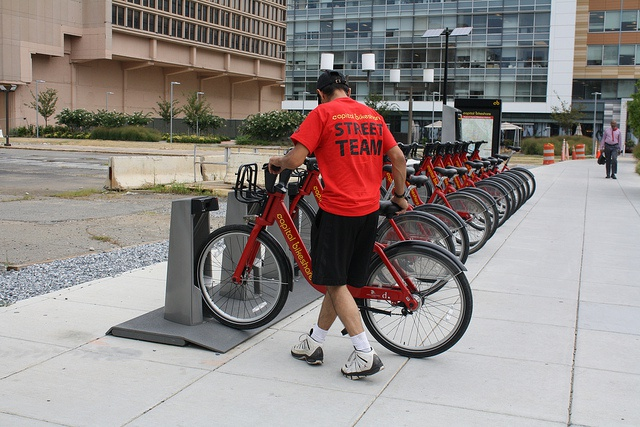Describe the objects in this image and their specific colors. I can see bicycle in gray, black, lightgray, and darkgray tones, people in gray, black, red, brown, and maroon tones, bicycle in gray, black, maroon, and darkgray tones, bicycle in gray, black, darkgray, and maroon tones, and bicycle in gray, black, darkgray, and maroon tones in this image. 